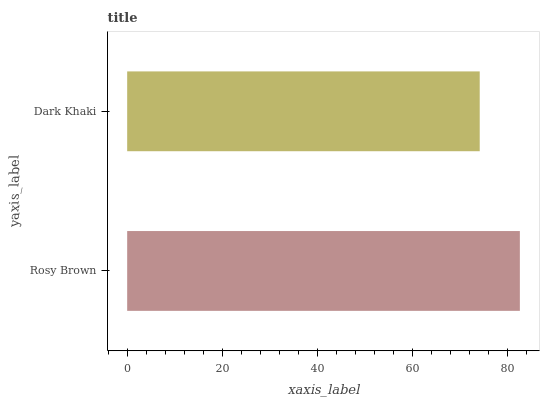Is Dark Khaki the minimum?
Answer yes or no. Yes. Is Rosy Brown the maximum?
Answer yes or no. Yes. Is Dark Khaki the maximum?
Answer yes or no. No. Is Rosy Brown greater than Dark Khaki?
Answer yes or no. Yes. Is Dark Khaki less than Rosy Brown?
Answer yes or no. Yes. Is Dark Khaki greater than Rosy Brown?
Answer yes or no. No. Is Rosy Brown less than Dark Khaki?
Answer yes or no. No. Is Rosy Brown the high median?
Answer yes or no. Yes. Is Dark Khaki the low median?
Answer yes or no. Yes. Is Dark Khaki the high median?
Answer yes or no. No. Is Rosy Brown the low median?
Answer yes or no. No. 